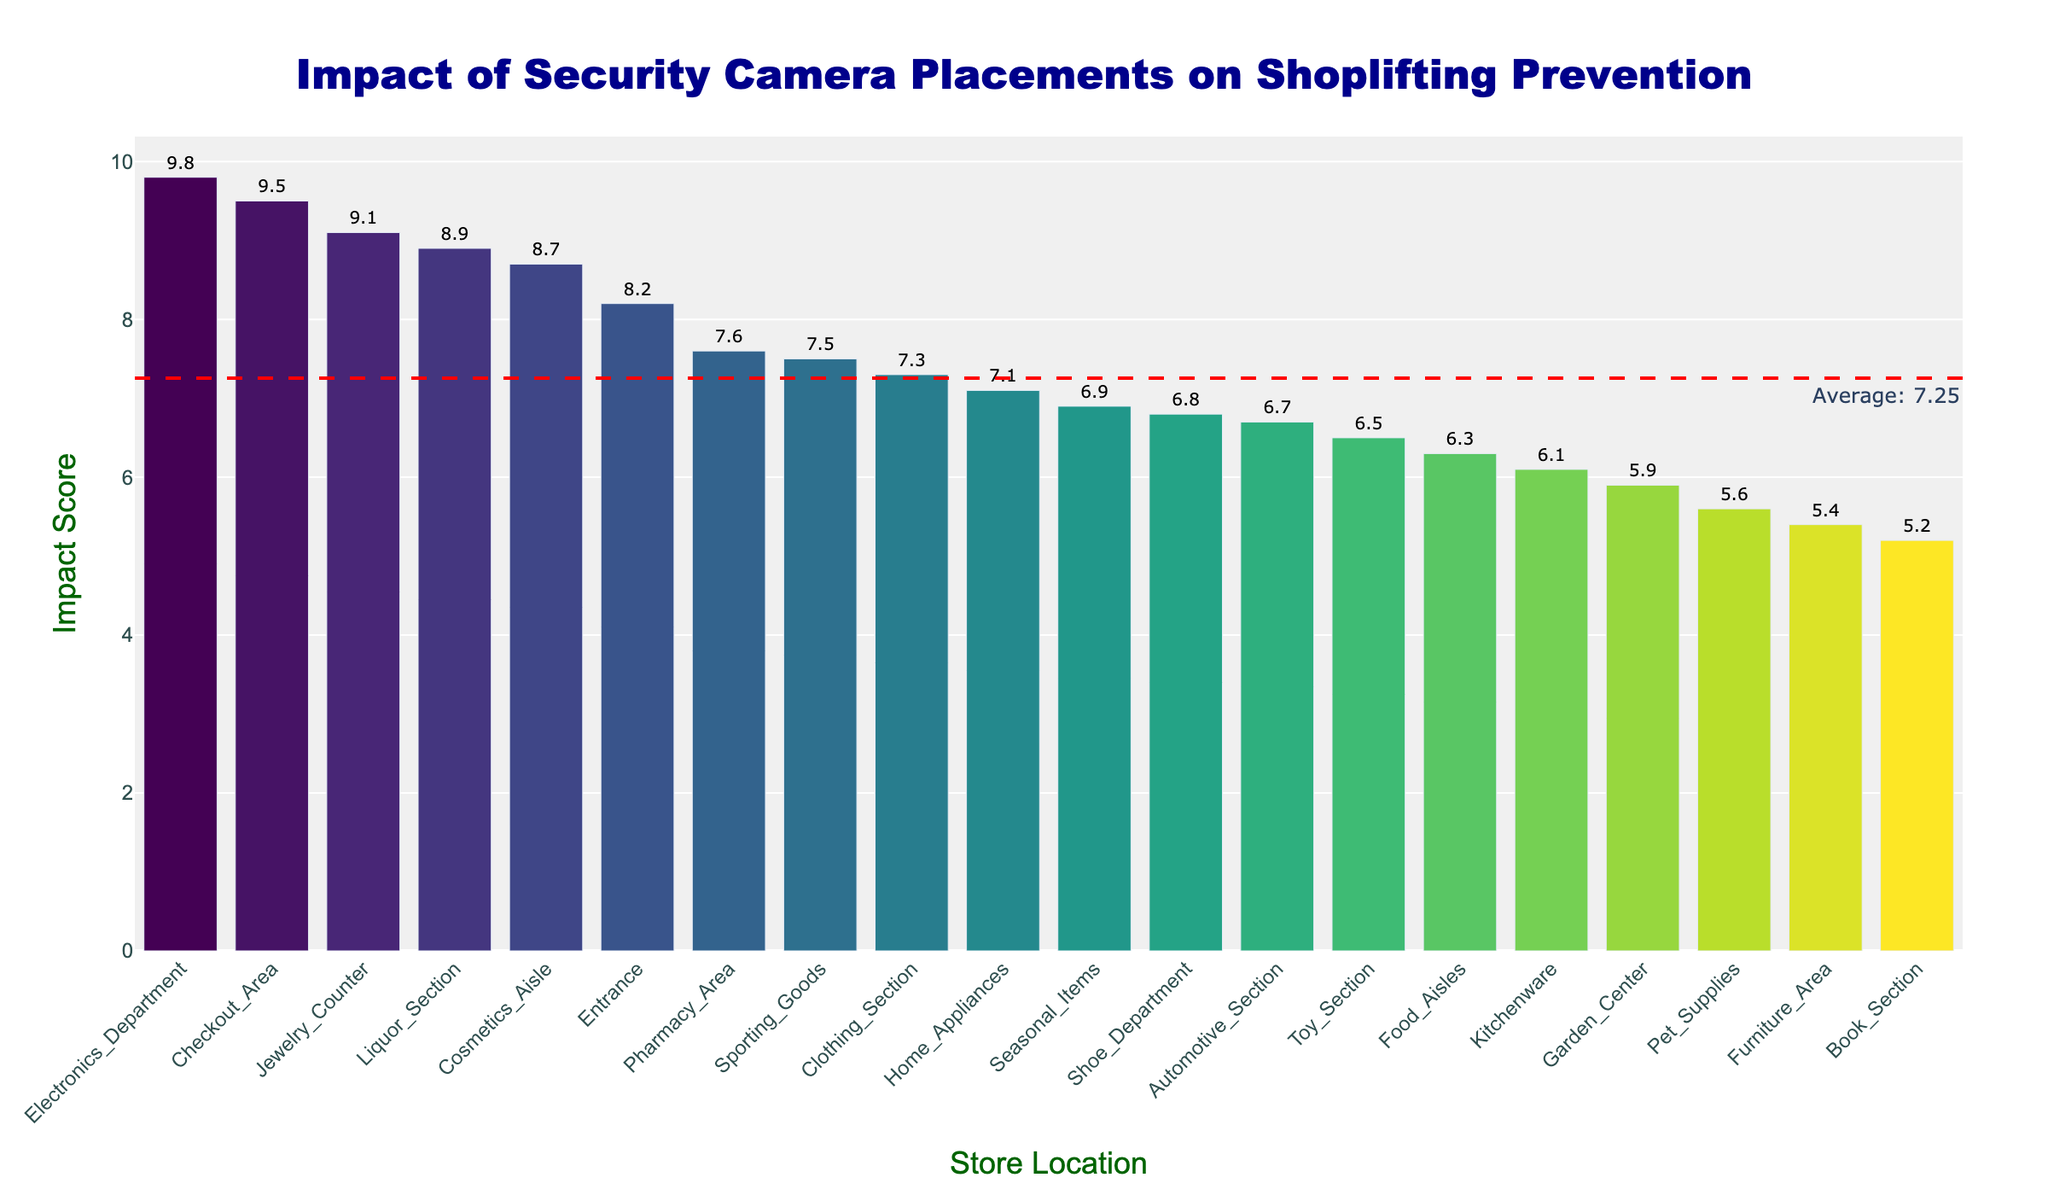Which store location has the highest impact score? By observing the figure, the bar corresponding to the Electronics Department is the tallest and reaches the highest value on the y-axis, indicating it has the highest impact score.
Answer: Electronics Department What's the average impact score across all store locations? The figure includes a horizontal dashed line with an annotation text indicating the average impact score. By reading this annotation, we can find the average score.
Answer: 7.14 How many store locations have an impact score higher than the average? From the figure, any bar that extends above the horizontal dashed line representing the average impact score indicates a higher-than-average value. Count these bars.
Answer: 8 Which store locations have an impact score below 6? By identifying the bars that fall below the horizontal 6 mark on the y-axis in the figure, we can determine which locations have an impact score below 6.
Answer: Garden Center, Book Section, Pet Supplies, Furniture Area By how much does the impact score of the Electronics Department exceed that of the Toy Section? Compare the height of the bar for the Electronics Department to the bar for the Toy Section. Subtract the impact score of Toy Section from that of the Electronics Department.
Answer: 3.3 Which store locations are closest to the average impact score? Looking at the bars that align closely with the horizontal dashed line representing the average impact score, we can identify the locations closest to this value.
Answer: Pharmacy Area, Sporting Goods What is the difference between the highest and lowest impact scores? Identify the highest bar (Electronics Department) and the lowest bar (Book Section). Subtract the lowest impact score from the highest impact score.
Answer: 4.6 Which sections have an impact score of 9 or above? Locate and read the bars that reach or extend beyond the 9 mark on the y-axis in the figure.
Answer: Checkout Area, Electronics Department, Jewelry Counter What is the median impact score of all the store locations? To determine the median impact score, we need to sort the impact scores in ascending order and find the middle value in the sorted list. If there's an even number of scores, it would be the average of the two middle scores. Based on the figure, a detailed look shows the sorted values around the middle range are roughly around 7.3 and 7.5, but to be precise sorting is recommended.
Answer: 7.3 